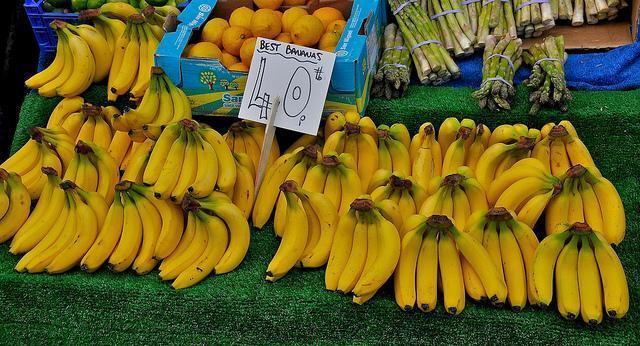How many different type of produce are shown?
Give a very brief answer. 3. How many oranges are visible?
Give a very brief answer. 1. How many bananas are there?
Give a very brief answer. 10. 